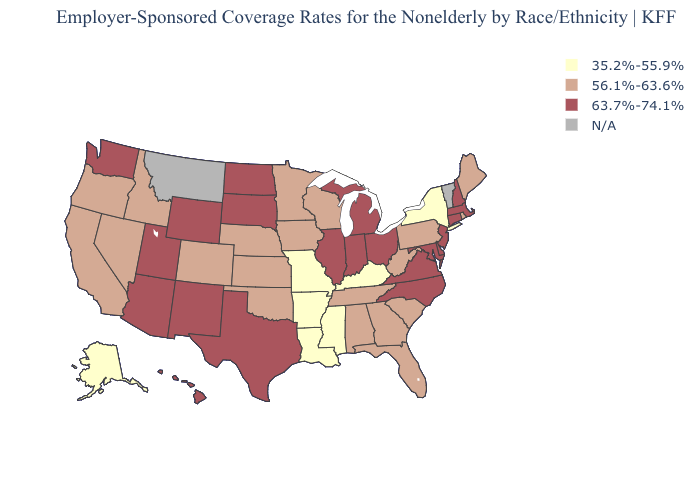Name the states that have a value in the range 35.2%-55.9%?
Short answer required. Alaska, Arkansas, Kentucky, Louisiana, Mississippi, Missouri, New York. Among the states that border New York , which have the lowest value?
Be succinct. Pennsylvania. What is the value of Ohio?
Give a very brief answer. 63.7%-74.1%. What is the lowest value in states that border Missouri?
Keep it brief. 35.2%-55.9%. What is the lowest value in the West?
Answer briefly. 35.2%-55.9%. Name the states that have a value in the range 35.2%-55.9%?
Write a very short answer. Alaska, Arkansas, Kentucky, Louisiana, Mississippi, Missouri, New York. Name the states that have a value in the range 56.1%-63.6%?
Keep it brief. Alabama, California, Colorado, Florida, Georgia, Idaho, Iowa, Kansas, Maine, Minnesota, Nebraska, Nevada, Oklahoma, Oregon, Pennsylvania, Rhode Island, South Carolina, Tennessee, West Virginia, Wisconsin. What is the value of Montana?
Write a very short answer. N/A. What is the value of Missouri?
Keep it brief. 35.2%-55.9%. What is the highest value in the Northeast ?
Quick response, please. 63.7%-74.1%. Does Georgia have the lowest value in the USA?
Give a very brief answer. No. Among the states that border Idaho , which have the highest value?
Keep it brief. Utah, Washington, Wyoming. What is the value of Indiana?
Be succinct. 63.7%-74.1%. 